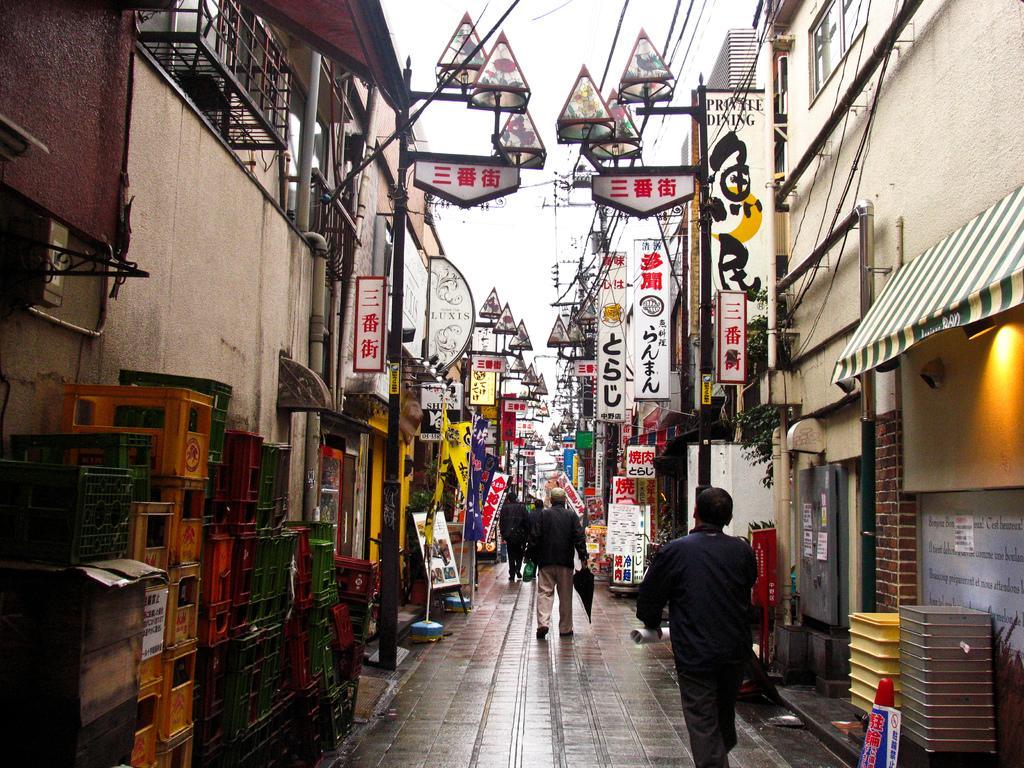Could you give a brief overview of what you see in this image? This image is taken outdoors. At the bottom of the image there is a floor. On the left and right sides of the image there are many buildings. There are many pipes. There are many boards with text on them. There is a flag and there are many objects. In the middle of the image a few people are walking on the floor. 